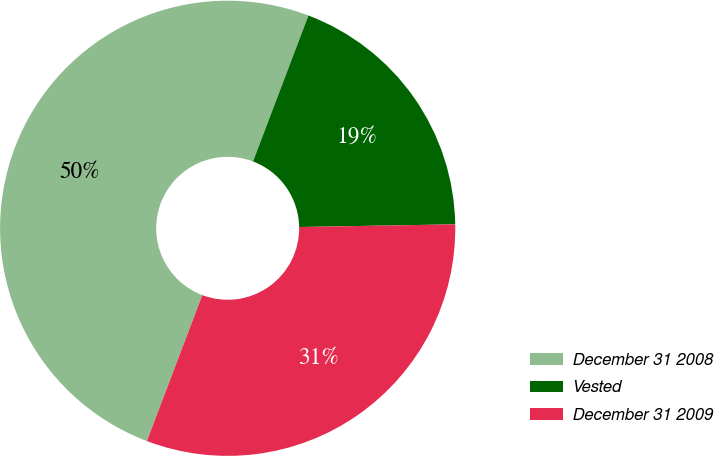Convert chart. <chart><loc_0><loc_0><loc_500><loc_500><pie_chart><fcel>December 31 2008<fcel>Vested<fcel>December 31 2009<nl><fcel>50.0%<fcel>18.95%<fcel>31.05%<nl></chart> 